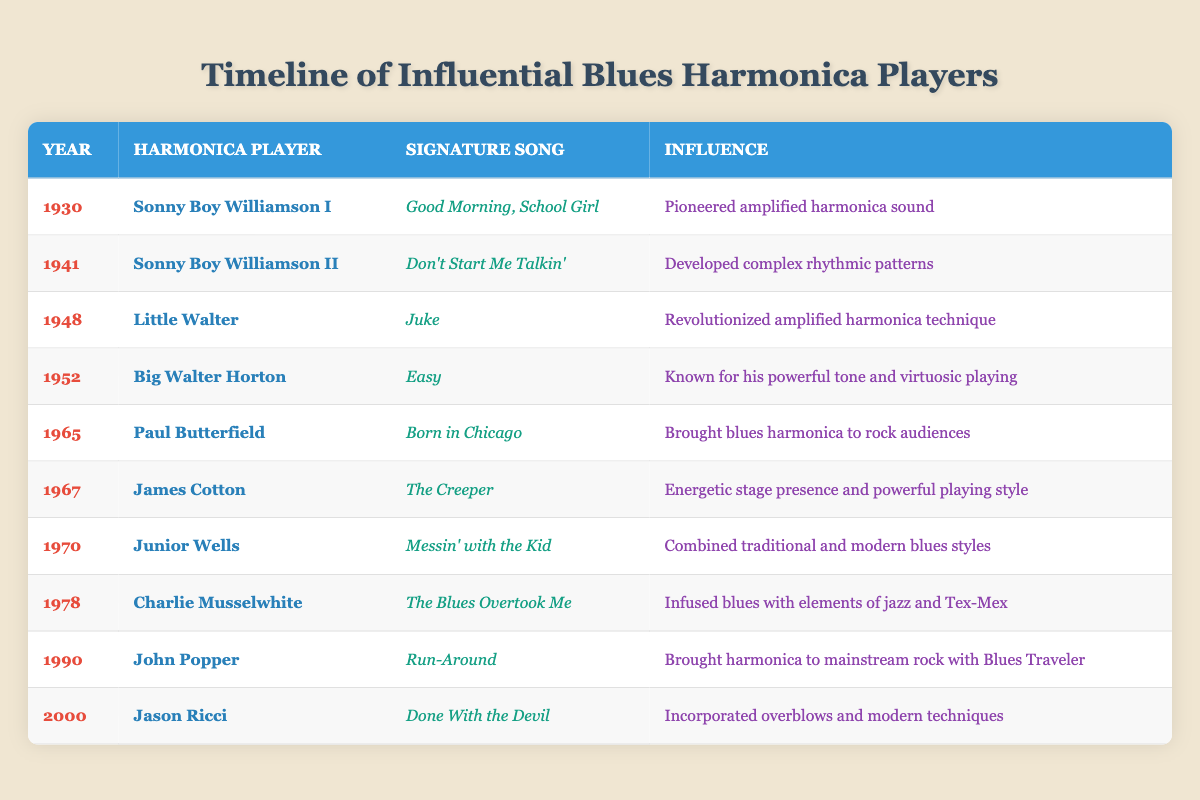What year did Little Walter release "Juke"? Looking at the table, the row for Little Walter shows that he released "Juke" in the year 1948.
Answer: 1948 Which harmonica player is known for pioneering amplified harmonica sound? According to the table, Sonny Boy Williamson I is noted for pioneering the amplified harmonica sound, as stated in the "Influence" column for the year 1930.
Answer: Sonny Boy Williamson I How many years apart are the signature songs "Don't Start Me Talkin'" and "Run-Around"? "Don't Start Me Talkin'" was released in 1941 and "Run-Around" in 1990. To find the difference, subtract 1941 from 1990, giving us 1990 - 1941 = 49 years.
Answer: 49 years Did any harmonica player in the table infuse blues with elements of jazz and Tex-Mex? Yes, the table indicates that Charlie Musselwhite, in 1978, infused blues with elements of jazz and Tex-Mex as noted in the "Influence" column.
Answer: Yes Which harmonica player had a combined influence of traditional and modern blues styles? Junior Wells is the player who combined traditional and modern blues styles, as indicated in the table for the year 1970.
Answer: Junior Wells What is the influence of Paul Butterfield according to the table? The table states that Paul Butterfield brought blues harmonica to rock audiences, which is mentioned in the "Influence" column for the year 1965.
Answer: Brought blues harmonica to rock audiences Who had the most recent signature song listed in the table? The most recent signature song listed is "Done With the Devil" by Jason Ricci in the year 2000. This is determined by comparing the years in the table and identifying the last one.
Answer: Jason Ricci Which two players are directly associated with the years 1941 and 1948? Sonny Boy Williamson II is associated with 1941 and Little Walter with 1948, as indicated in the respective rows of the table.
Answer: Sonny Boy Williamson II and Little Walter List the unique influences mentioned for the harmonica players from the table. To compile the unique influences, we look at the "Influence" column and identify each distinct influence: "Pioneered amplified harmonica sound," "Developed complex rhythmic patterns," "Revolutionized amplified harmonica technique," "Known for his powerful tone and virtuosic playing," "Brought blues harmonica to rock audiences," "Energetic stage presence and powerful playing style," "Combined traditional and modern blues styles," "Infused blues with elements of jazz and Tex-Mex," "Brought harmonica to mainstream rock with Blues Traveler," "Incorporated overblows and modern techniques." These are all noted in the table.
Answer: Pioneered amplified harmonica sound; Developed complex rhythmic patterns; Revolutionized amplified harmonica technique; Known for his powerful tone and virtuosic playing; Brought blues harmonica to rock audiences; Energetic stage presence and powerful playing style; Combined traditional and modern blues styles; Infused blues with elements of jazz and Tex-Mex; Brought harmonica to mainstream rock with Blues Traveler; Incorporated overblows and modern techniques 